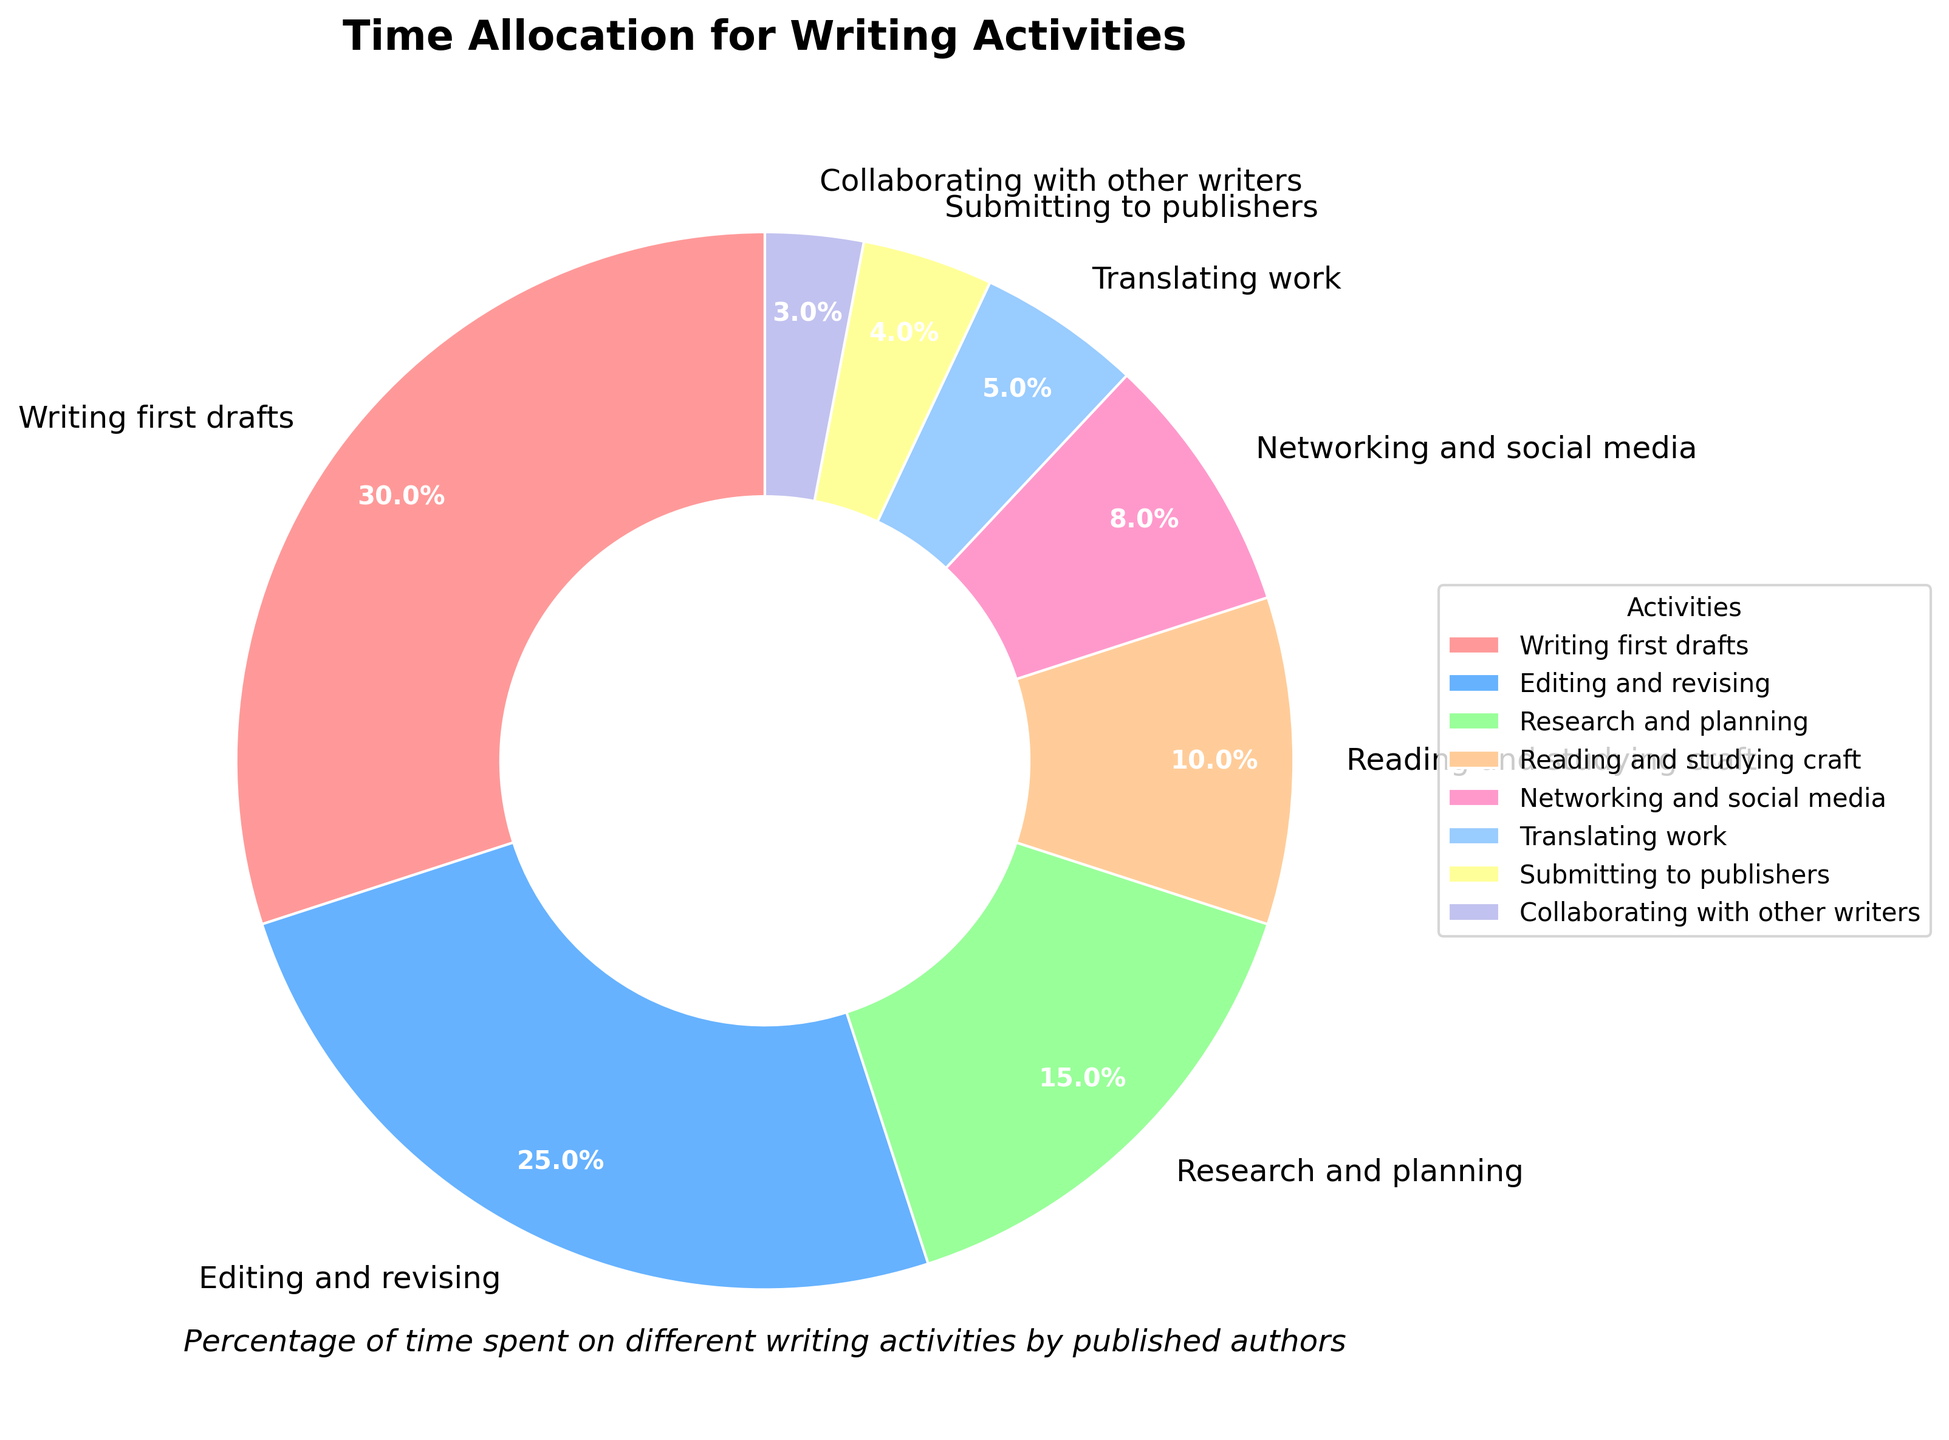Which writing activity has the highest percentage of time allocation? The writing activity with the highest percentage can be found by identifying the largest segment in the pie chart. The "Writing first drafts" segment is the largest, with a percentage of 30%.
Answer: Writing first drafts How much more time do authors spend on editing and revising compared to submitting to publishers? To find how much more time is spent on editing and revising compared to submitting to publishers, subtract the percentage for submitting to publishers (4%) from the percentage for editing and revising (25%). The result is 25% - 4% = 21%.
Answer: 21% What is the total percentage of time spent on research and planning, and reading and studying craft combined? Add the percentage for research and planning (15%) to the percentage for reading and studying craft (10%). The result is 15% + 10% = 25%.
Answer: 25% Which activity occupies the smallest portion of the authors' time, and what percentage of time is devoted to it? The smallest portion can be identified by finding the smallest segment in the pie chart. The segment for "Collaborating with other writers" is the smallest, with a percentage of 3%.
Answer: Collaborating with other writers (3%) Are authors spending more time on networking and social media or translating work? By how much? Compare the percentages for networking and social media (8%) and translating work (5%). Networking and social media has a larger percentage. Subtract the smaller percentage from the larger: 8% - 5% = 3%.
Answer: Networking and social media by 3% What percentage of the authors' time is not spent on writing first drafts or editing and revising combined? Add the percentages for writing first drafts (30%) and editing and revising (25%) first. Then subtract this sum from 100%: 100% - (30% + 25%) = 100% - 55% = 45%.
Answer: 45% Which two activities combined have the same total percentage of time spent as editing and revising? Editing and revising takes up 25% of the time. Look for two activities that add up to 25%. Research and planning (15%) and reading and studying craft (10%) together equal 25%.
Answer: Research and planning, and reading and studying craft What proportion of the total time is allocated to more than one activity, based on the visual width of the segments? The visual width proportionate to their respective percentage shows that more than one activity is spending less time on it. Here, less than 10% are two activities; 5% for translating work and 4% for submitting to publishers; and another 3% for collaborating with other writers. Together, they account for their combined percentages; translating work (5%) + submitting to publishers (4%) + collaborating with other writers (3%) = 12%.
Answer: 12% 